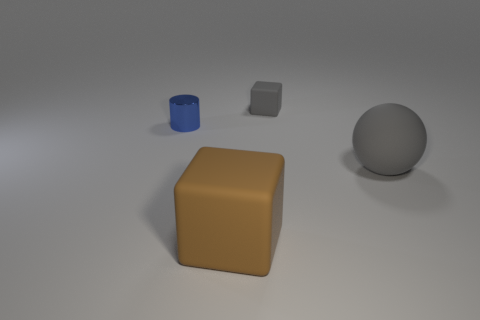Add 1 small purple matte cubes. How many objects exist? 5 Subtract all brown cubes. How many cubes are left? 1 Subtract 1 balls. How many balls are left? 0 Add 1 large cyan rubber cubes. How many large cyan rubber cubes exist? 1 Subtract 0 red cylinders. How many objects are left? 4 Subtract all cylinders. How many objects are left? 3 Subtract all brown blocks. Subtract all blue cylinders. How many blocks are left? 1 Subtract all cyan spheres. How many cyan cylinders are left? 0 Subtract all blue cubes. Subtract all large gray objects. How many objects are left? 3 Add 4 shiny objects. How many shiny objects are left? 5 